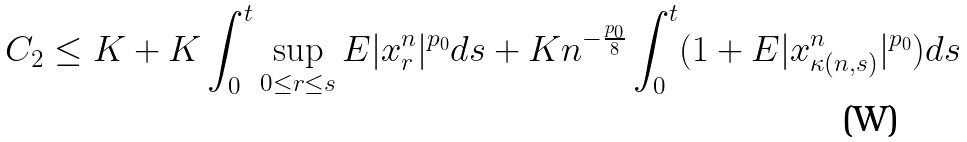<formula> <loc_0><loc_0><loc_500><loc_500>C _ { 2 } & \leq K + K \int _ { 0 } ^ { t } \sup _ { 0 \leq r \leq s } E | x _ { r } ^ { n } | ^ { p _ { 0 } } d s + K n ^ { - \frac { p _ { 0 } } { 8 } } \int _ { 0 } ^ { t } ( 1 + E | x _ { \kappa ( n , s ) } ^ { n } | ^ { p _ { 0 } } ) d s</formula> 